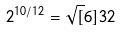Convert formula to latex. <formula><loc_0><loc_0><loc_500><loc_500>2 ^ { 1 0 / 1 2 } = \sqrt { [ } 6 ] { 3 2 }</formula> 